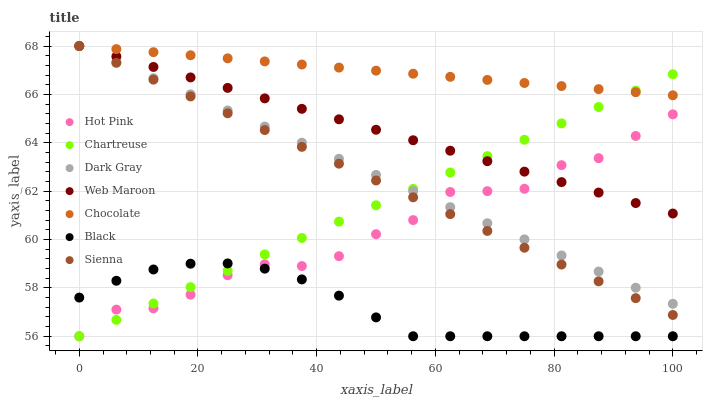Does Black have the minimum area under the curve?
Answer yes or no. Yes. Does Chocolate have the maximum area under the curve?
Answer yes or no. Yes. Does Hot Pink have the minimum area under the curve?
Answer yes or no. No. Does Hot Pink have the maximum area under the curve?
Answer yes or no. No. Is Web Maroon the smoothest?
Answer yes or no. Yes. Is Hot Pink the roughest?
Answer yes or no. Yes. Is Hot Pink the smoothest?
Answer yes or no. No. Is Web Maroon the roughest?
Answer yes or no. No. Does Hot Pink have the lowest value?
Answer yes or no. Yes. Does Web Maroon have the lowest value?
Answer yes or no. No. Does Dark Gray have the highest value?
Answer yes or no. Yes. Does Hot Pink have the highest value?
Answer yes or no. No. Is Black less than Dark Gray?
Answer yes or no. Yes. Is Dark Gray greater than Black?
Answer yes or no. Yes. Does Hot Pink intersect Dark Gray?
Answer yes or no. Yes. Is Hot Pink less than Dark Gray?
Answer yes or no. No. Is Hot Pink greater than Dark Gray?
Answer yes or no. No. Does Black intersect Dark Gray?
Answer yes or no. No. 